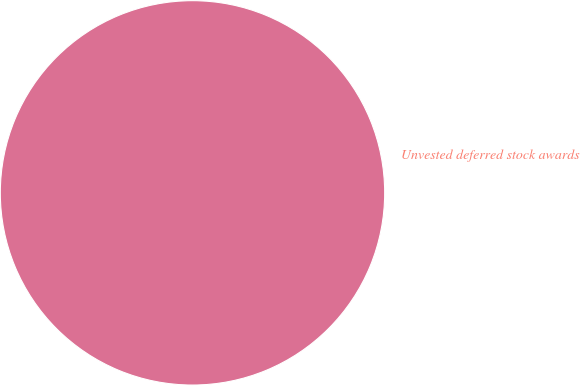Convert chart. <chart><loc_0><loc_0><loc_500><loc_500><pie_chart><fcel>Unvested deferred stock awards<nl><fcel>100.0%<nl></chart> 